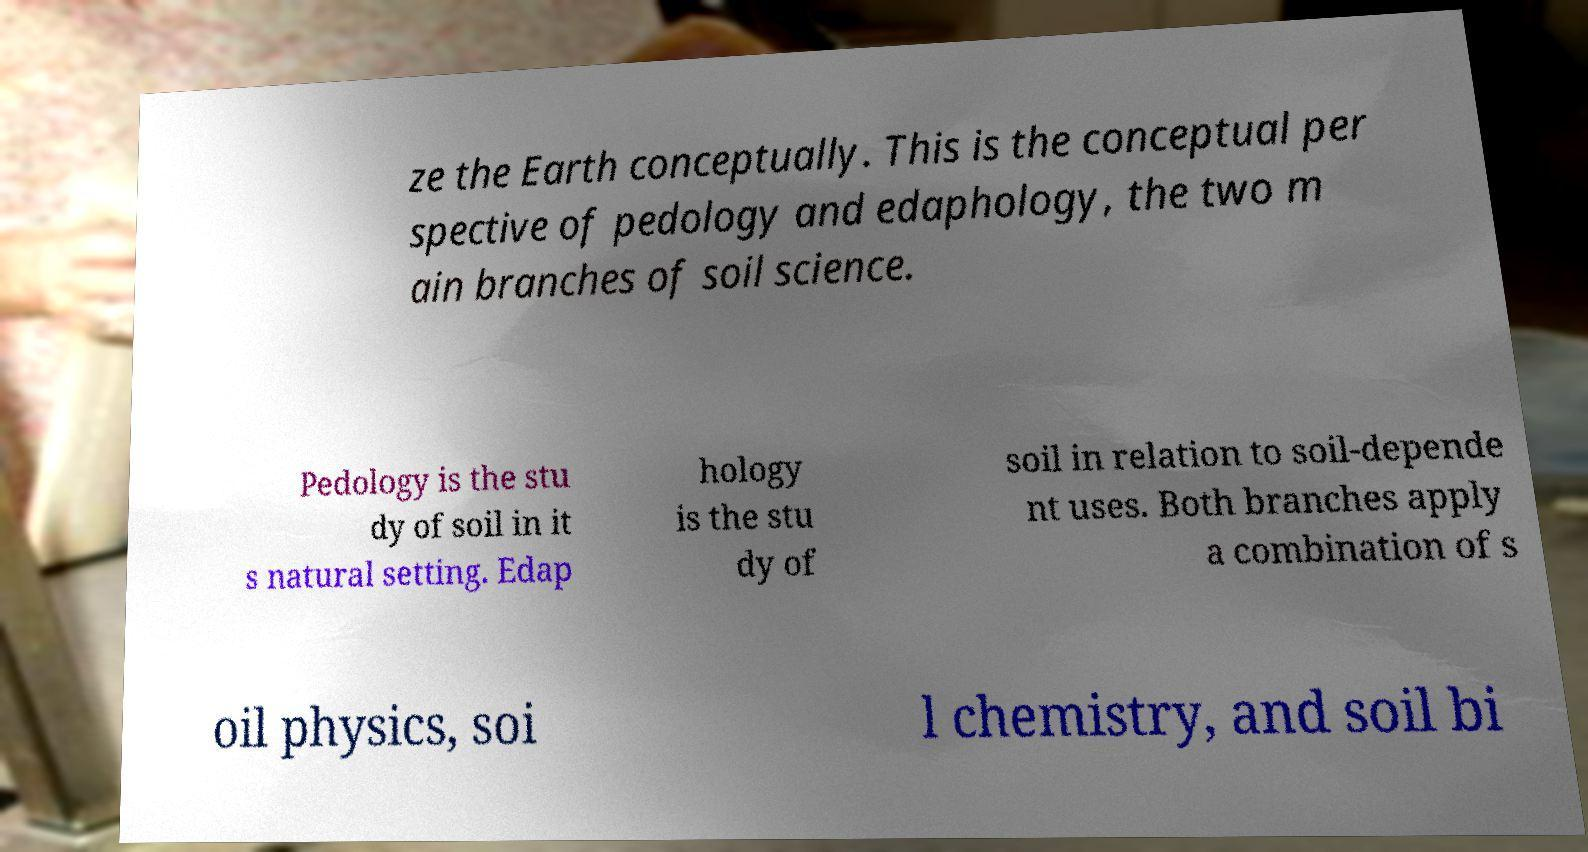Could you assist in decoding the text presented in this image and type it out clearly? ze the Earth conceptually. This is the conceptual per spective of pedology and edaphology, the two m ain branches of soil science. Pedology is the stu dy of soil in it s natural setting. Edap hology is the stu dy of soil in relation to soil-depende nt uses. Both branches apply a combination of s oil physics, soi l chemistry, and soil bi 